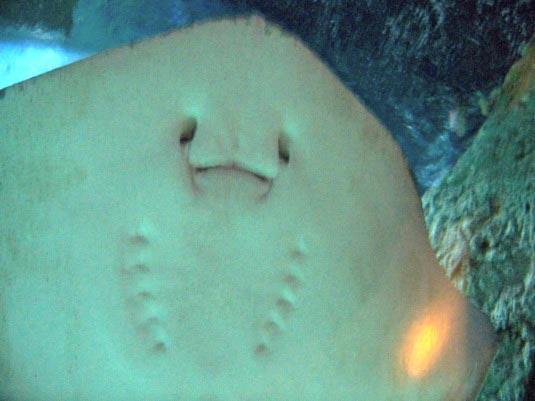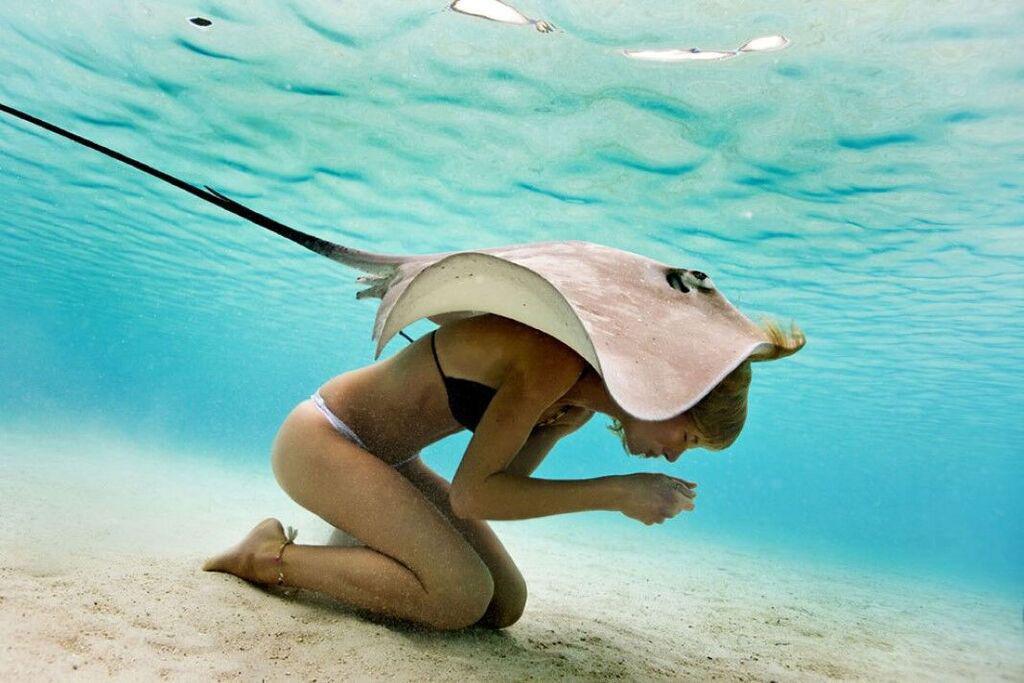The first image is the image on the left, the second image is the image on the right. Evaluate the accuracy of this statement regarding the images: "There is a human visible in one of the images.". Is it true? Answer yes or no. Yes. The first image is the image on the left, the second image is the image on the right. Examine the images to the left and right. Is the description "There are sting rays in both images." accurate? Answer yes or no. Yes. 